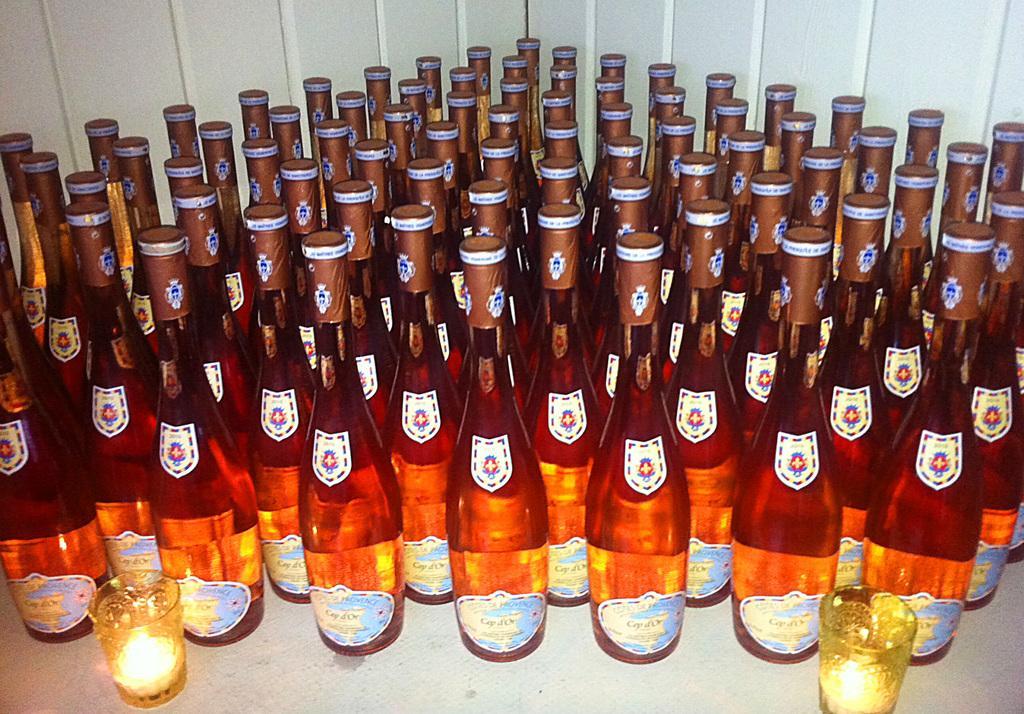Can you describe this image briefly? In this image I can see number of bottles and two glasses. 